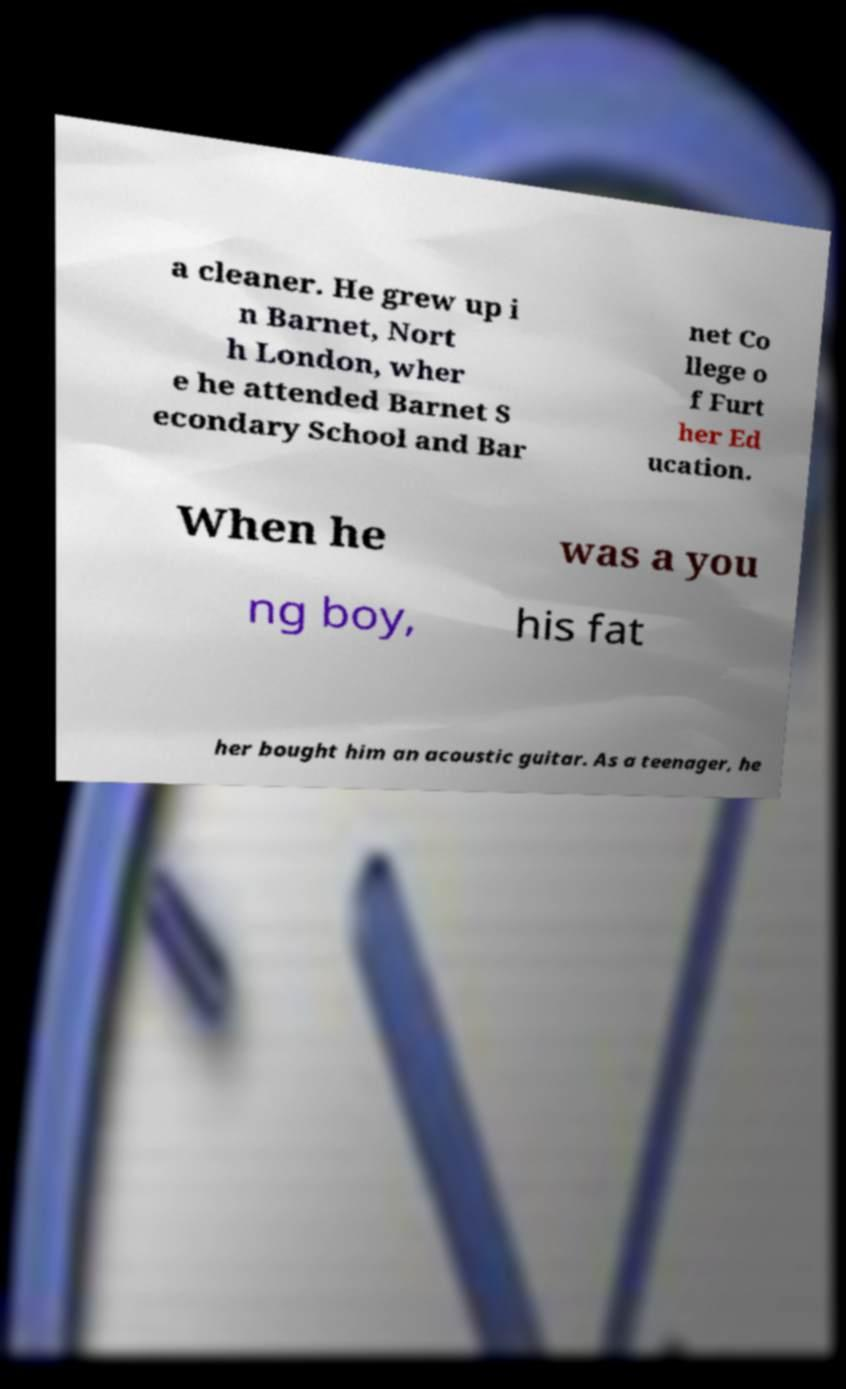Can you read and provide the text displayed in the image?This photo seems to have some interesting text. Can you extract and type it out for me? a cleaner. He grew up i n Barnet, Nort h London, wher e he attended Barnet S econdary School and Bar net Co llege o f Furt her Ed ucation. When he was a you ng boy, his fat her bought him an acoustic guitar. As a teenager, he 